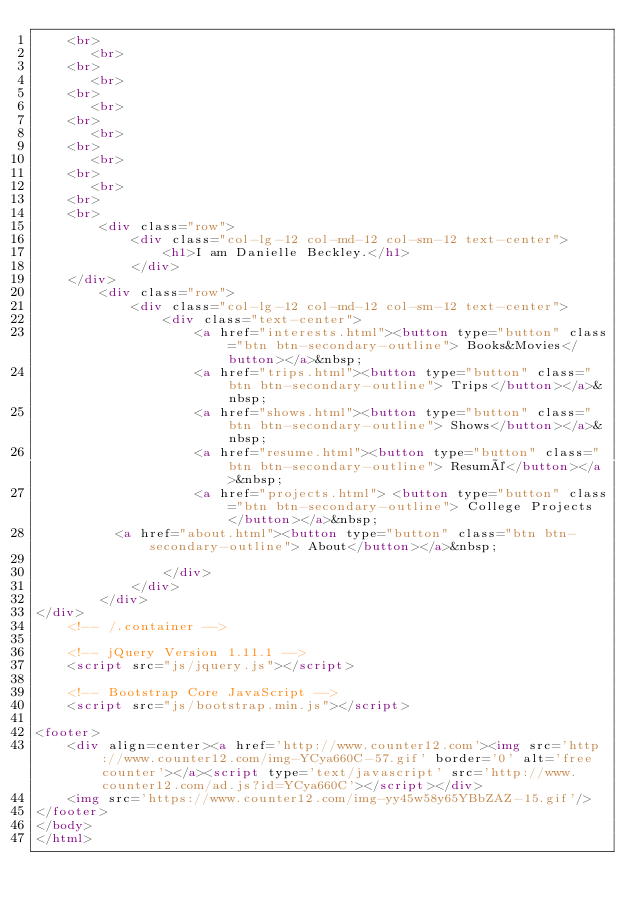<code> <loc_0><loc_0><loc_500><loc_500><_HTML_>    <br>
       <br>
    <br>
       <br>
    <br>
       <br>
    <br>
       <br>
    <br>
       <br>
    <br>
       <br>
    <br>
    <br>
        <div class="row">
            <div class="col-lg-12 col-md-12 col-sm-12 text-center">
                <h1>I am Danielle Beckley.</h1>
            </div>
    </div>
        <div class="row">
            <div class="col-lg-12 col-md-12 col-sm-12 text-center">
                <div class="text-center">
                    <a href="interests.html"><button type="button" class="btn btn-secondary-outline"> Books&Movies</button></a>&nbsp;
                    <a href="trips.html"><button type="button" class="btn btn-secondary-outline"> Trips</button></a>&nbsp;
                    <a href="shows.html"><button type="button" class="btn btn-secondary-outline"> Shows</button></a>&nbsp;
                    <a href="resume.html"><button type="button" class="btn btn-secondary-outline"> Resumé</button></a>&nbsp;
                    <a href="projects.html"> <button type="button" class="btn btn-secondary-outline"> College Projects </button></a>&nbsp;
					<a href="about.html"><button type="button" class="btn btn-secondary-outline"> About</button></a>&nbsp;
                
                </div>
            </div>
        </div>
</div>
    <!-- /.container -->

    <!-- jQuery Version 1.11.1 -->
    <script src="js/jquery.js"></script>

    <!-- Bootstrap Core JavaScript -->
    <script src="js/bootstrap.min.js"></script>

<footer>
    <div align=center><a href='http://www.counter12.com'><img src='http://www.counter12.com/img-YCya660C-57.gif' border='0' alt='free counter'></a><script type='text/javascript' src='http://www.counter12.com/ad.js?id=YCya660C'></script></div>
    <img src='https://www.counter12.com/img-yy45w58y65YBbZAZ-15.gif'/>
</footer>
</body>
</html>
</code> 